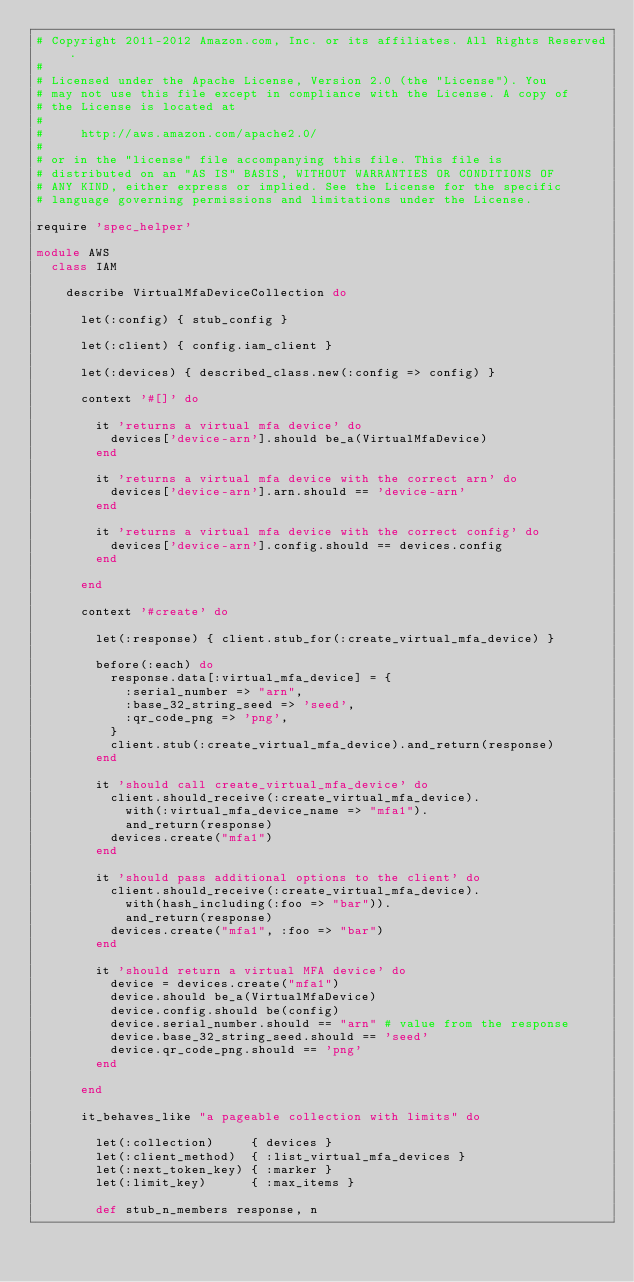<code> <loc_0><loc_0><loc_500><loc_500><_Ruby_># Copyright 2011-2012 Amazon.com, Inc. or its affiliates. All Rights Reserved.
#
# Licensed under the Apache License, Version 2.0 (the "License"). You
# may not use this file except in compliance with the License. A copy of
# the License is located at
#
#     http://aws.amazon.com/apache2.0/
#
# or in the "license" file accompanying this file. This file is
# distributed on an "AS IS" BASIS, WITHOUT WARRANTIES OR CONDITIONS OF
# ANY KIND, either express or implied. See the License for the specific
# language governing permissions and limitations under the License.

require 'spec_helper'

module AWS
  class IAM

    describe VirtualMfaDeviceCollection do

      let(:config) { stub_config }

      let(:client) { config.iam_client }

      let(:devices) { described_class.new(:config => config) }

      context '#[]' do

        it 'returns a virtual mfa device' do
          devices['device-arn'].should be_a(VirtualMfaDevice)
        end
        
        it 'returns a virtual mfa device with the correct arn' do
          devices['device-arn'].arn.should == 'device-arn'
        end
        
        it 'returns a virtual mfa device with the correct config' do
          devices['device-arn'].config.should == devices.config
        end

      end

      context '#create' do

        let(:response) { client.stub_for(:create_virtual_mfa_device) }

        before(:each) do
          response.data[:virtual_mfa_device] = {
            :serial_number => "arn",
            :base_32_string_seed => 'seed',
            :qr_code_png => 'png',
          }
          client.stub(:create_virtual_mfa_device).and_return(response)
        end

        it 'should call create_virtual_mfa_device' do
          client.should_receive(:create_virtual_mfa_device).
            with(:virtual_mfa_device_name => "mfa1").
            and_return(response)
          devices.create("mfa1")
        end

        it 'should pass additional options to the client' do
          client.should_receive(:create_virtual_mfa_device).
            with(hash_including(:foo => "bar")).
            and_return(response)
          devices.create("mfa1", :foo => "bar")
        end

        it 'should return a virtual MFA device' do
          device = devices.create("mfa1")
          device.should be_a(VirtualMfaDevice)
          device.config.should be(config)
          device.serial_number.should == "arn" # value from the response
          device.base_32_string_seed.should == 'seed'
          device.qr_code_png.should == 'png'
        end

      end

      it_behaves_like "a pageable collection with limits" do

        let(:collection)     { devices }
        let(:client_method)  { :list_virtual_mfa_devices }
        let(:next_token_key) { :marker }
        let(:limit_key)      { :max_items }

        def stub_n_members response, n</code> 